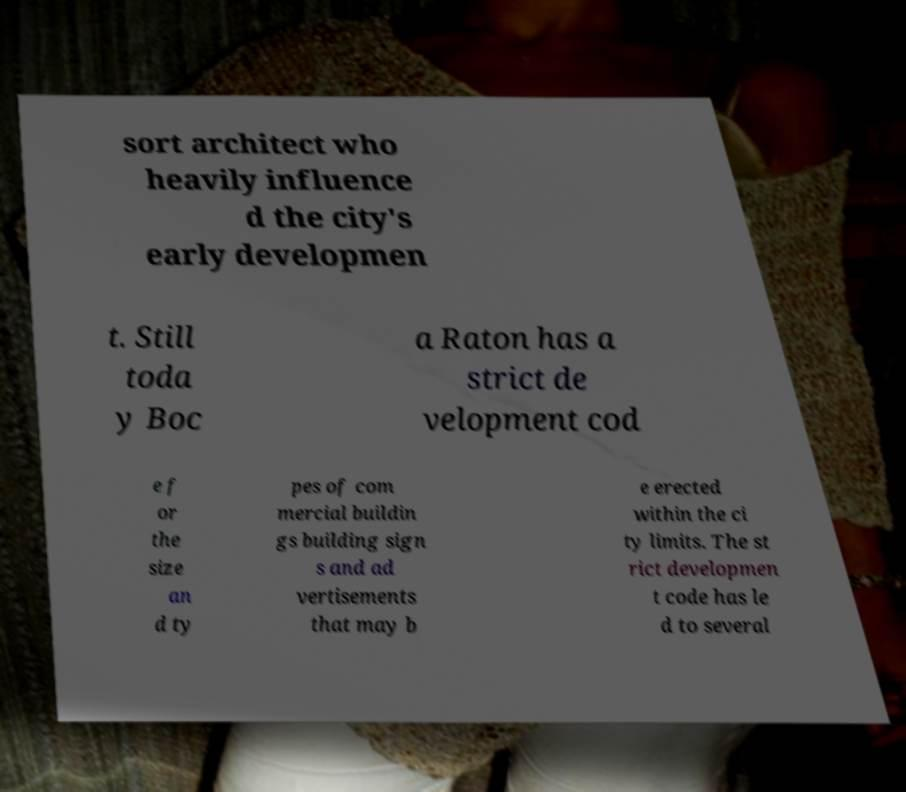There's text embedded in this image that I need extracted. Can you transcribe it verbatim? sort architect who heavily influence d the city's early developmen t. Still toda y Boc a Raton has a strict de velopment cod e f or the size an d ty pes of com mercial buildin gs building sign s and ad vertisements that may b e erected within the ci ty limits. The st rict developmen t code has le d to several 